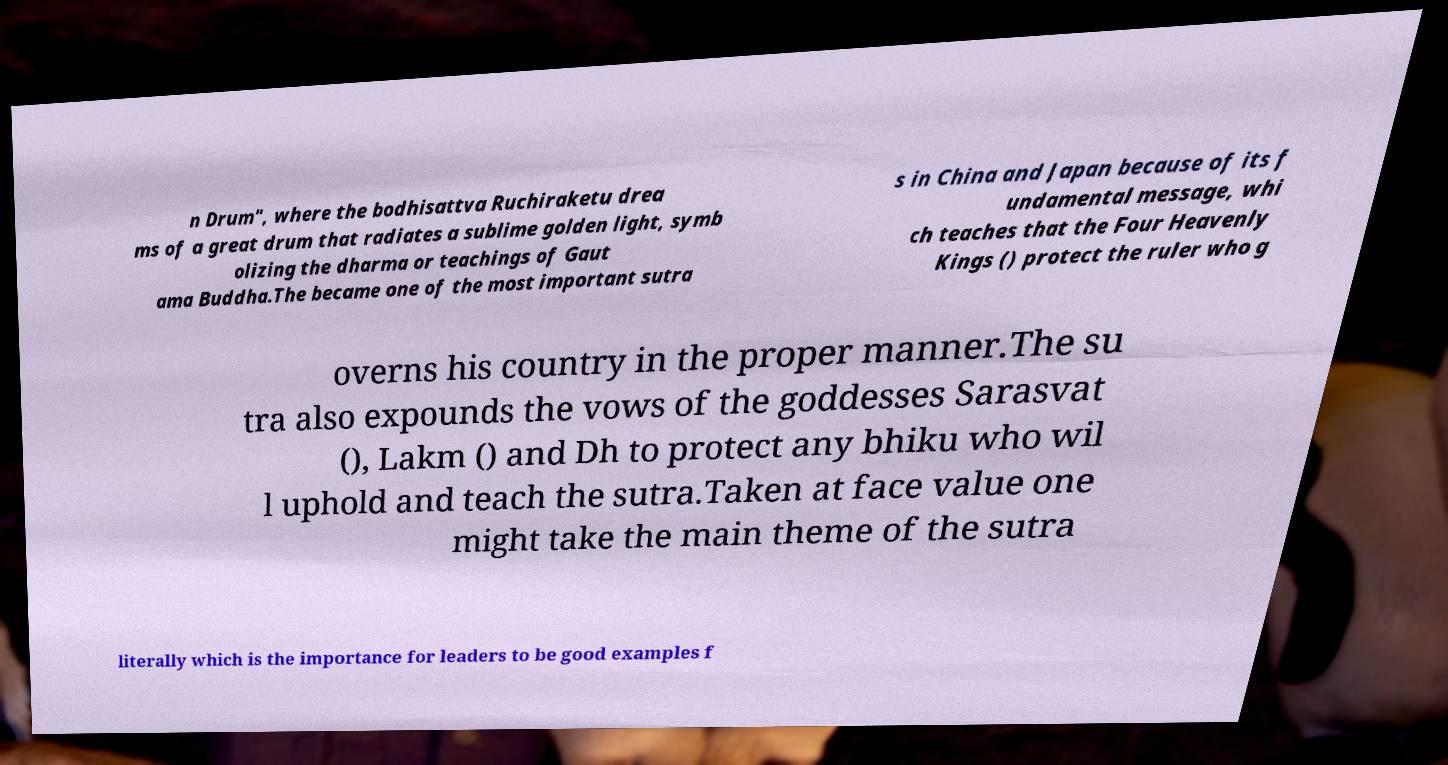Could you assist in decoding the text presented in this image and type it out clearly? n Drum", where the bodhisattva Ruchiraketu drea ms of a great drum that radiates a sublime golden light, symb olizing the dharma or teachings of Gaut ama Buddha.The became one of the most important sutra s in China and Japan because of its f undamental message, whi ch teaches that the Four Heavenly Kings () protect the ruler who g overns his country in the proper manner.The su tra also expounds the vows of the goddesses Sarasvat (), Lakm () and Dh to protect any bhiku who wil l uphold and teach the sutra.Taken at face value one might take the main theme of the sutra literally which is the importance for leaders to be good examples f 